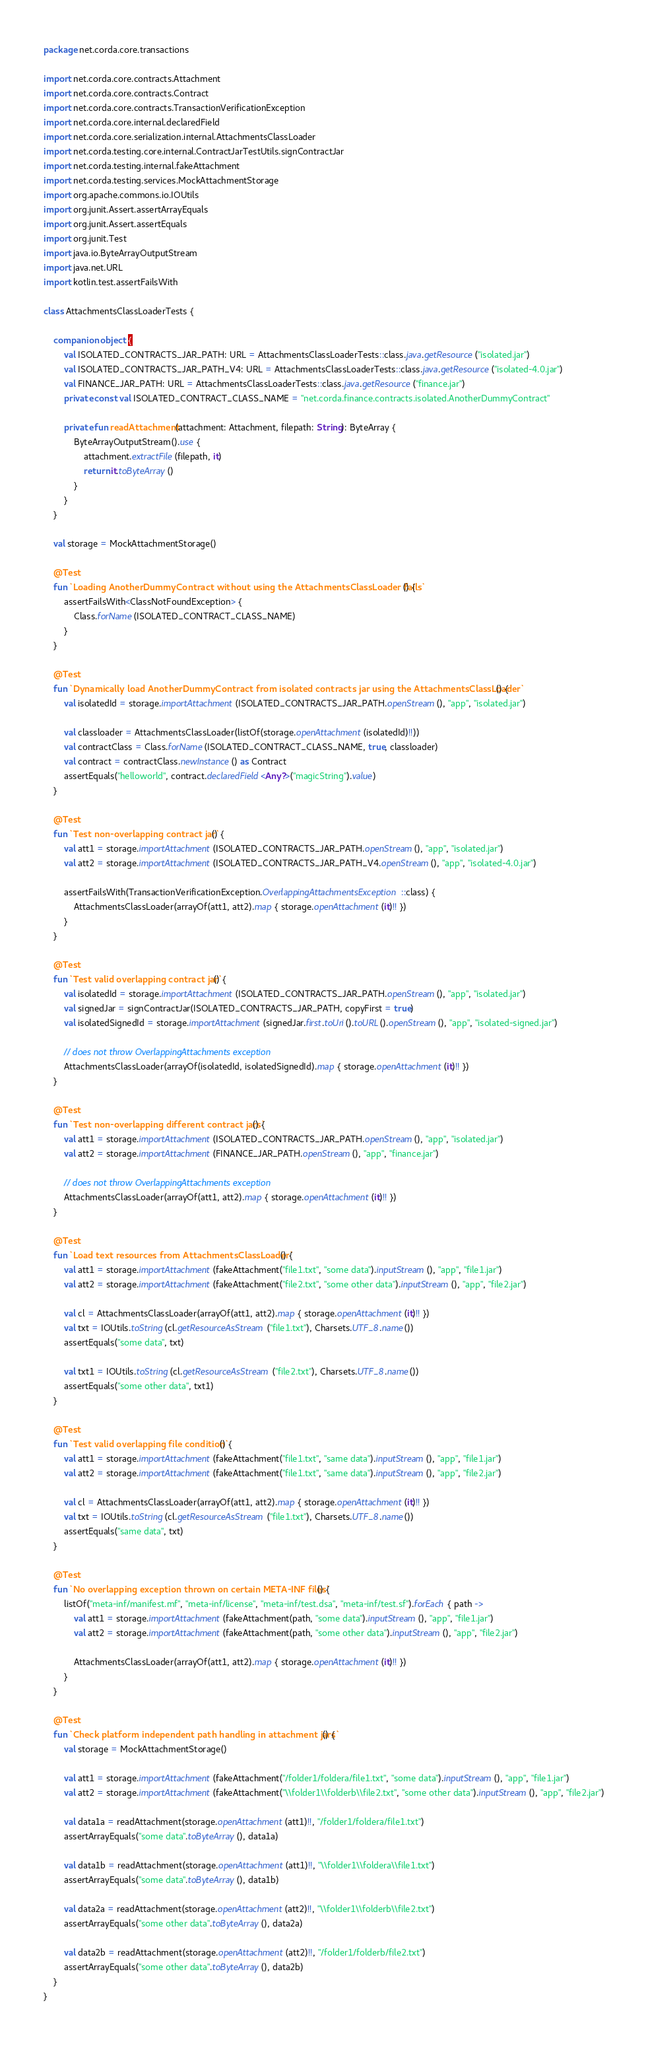<code> <loc_0><loc_0><loc_500><loc_500><_Kotlin_>package net.corda.core.transactions

import net.corda.core.contracts.Attachment
import net.corda.core.contracts.Contract
import net.corda.core.contracts.TransactionVerificationException
import net.corda.core.internal.declaredField
import net.corda.core.serialization.internal.AttachmentsClassLoader
import net.corda.testing.core.internal.ContractJarTestUtils.signContractJar
import net.corda.testing.internal.fakeAttachment
import net.corda.testing.services.MockAttachmentStorage
import org.apache.commons.io.IOUtils
import org.junit.Assert.assertArrayEquals
import org.junit.Assert.assertEquals
import org.junit.Test
import java.io.ByteArrayOutputStream
import java.net.URL
import kotlin.test.assertFailsWith

class AttachmentsClassLoaderTests {

    companion object {
        val ISOLATED_CONTRACTS_JAR_PATH: URL = AttachmentsClassLoaderTests::class.java.getResource("isolated.jar")
        val ISOLATED_CONTRACTS_JAR_PATH_V4: URL = AttachmentsClassLoaderTests::class.java.getResource("isolated-4.0.jar")
        val FINANCE_JAR_PATH: URL = AttachmentsClassLoaderTests::class.java.getResource("finance.jar")
        private const val ISOLATED_CONTRACT_CLASS_NAME = "net.corda.finance.contracts.isolated.AnotherDummyContract"

        private fun readAttachment(attachment: Attachment, filepath: String): ByteArray {
            ByteArrayOutputStream().use {
                attachment.extractFile(filepath, it)
                return it.toByteArray()
            }
        }
    }

    val storage = MockAttachmentStorage()

    @Test
    fun `Loading AnotherDummyContract without using the AttachmentsClassLoader fails`() {
        assertFailsWith<ClassNotFoundException> {
            Class.forName(ISOLATED_CONTRACT_CLASS_NAME)
        }
    }

    @Test
    fun `Dynamically load AnotherDummyContract from isolated contracts jar using the AttachmentsClassLoader`() {
        val isolatedId = storage.importAttachment(ISOLATED_CONTRACTS_JAR_PATH.openStream(), "app", "isolated.jar")

        val classloader = AttachmentsClassLoader(listOf(storage.openAttachment(isolatedId)!!))
        val contractClass = Class.forName(ISOLATED_CONTRACT_CLASS_NAME, true, classloader)
        val contract = contractClass.newInstance() as Contract
        assertEquals("helloworld", contract.declaredField<Any?>("magicString").value)
    }

    @Test
    fun `Test non-overlapping contract jar`() {
        val att1 = storage.importAttachment(ISOLATED_CONTRACTS_JAR_PATH.openStream(), "app", "isolated.jar")
        val att2 = storage.importAttachment(ISOLATED_CONTRACTS_JAR_PATH_V4.openStream(), "app", "isolated-4.0.jar")

        assertFailsWith(TransactionVerificationException.OverlappingAttachmentsException::class) {
            AttachmentsClassLoader(arrayOf(att1, att2).map { storage.openAttachment(it)!! })
        }
    }

    @Test
    fun `Test valid overlapping contract jar`() {
        val isolatedId = storage.importAttachment(ISOLATED_CONTRACTS_JAR_PATH.openStream(), "app", "isolated.jar")
        val signedJar = signContractJar(ISOLATED_CONTRACTS_JAR_PATH, copyFirst = true)
        val isolatedSignedId = storage.importAttachment(signedJar.first.toUri().toURL().openStream(), "app", "isolated-signed.jar")

        // does not throw OverlappingAttachments exception
        AttachmentsClassLoader(arrayOf(isolatedId, isolatedSignedId).map { storage.openAttachment(it)!! })
    }

    @Test
    fun `Test non-overlapping different contract jars`() {
        val att1 = storage.importAttachment(ISOLATED_CONTRACTS_JAR_PATH.openStream(), "app", "isolated.jar")
        val att2 = storage.importAttachment(FINANCE_JAR_PATH.openStream(), "app", "finance.jar")

        // does not throw OverlappingAttachments exception
        AttachmentsClassLoader(arrayOf(att1, att2).map { storage.openAttachment(it)!! })
    }

    @Test
    fun `Load text resources from AttachmentsClassLoader`() {
        val att1 = storage.importAttachment(fakeAttachment("file1.txt", "some data").inputStream(), "app", "file1.jar")
        val att2 = storage.importAttachment(fakeAttachment("file2.txt", "some other data").inputStream(), "app", "file2.jar")

        val cl = AttachmentsClassLoader(arrayOf(att1, att2).map { storage.openAttachment(it)!! })
        val txt = IOUtils.toString(cl.getResourceAsStream("file1.txt"), Charsets.UTF_8.name())
        assertEquals("some data", txt)

        val txt1 = IOUtils.toString(cl.getResourceAsStream("file2.txt"), Charsets.UTF_8.name())
        assertEquals("some other data", txt1)
    }

    @Test
    fun `Test valid overlapping file condition`() {
        val att1 = storage.importAttachment(fakeAttachment("file1.txt", "same data").inputStream(), "app", "file1.jar")
        val att2 = storage.importAttachment(fakeAttachment("file1.txt", "same data").inputStream(), "app", "file2.jar")

        val cl = AttachmentsClassLoader(arrayOf(att1, att2).map { storage.openAttachment(it)!! })
        val txt = IOUtils.toString(cl.getResourceAsStream("file1.txt"), Charsets.UTF_8.name())
        assertEquals("same data", txt)
    }

    @Test
    fun `No overlapping exception thrown on certain META-INF files`() {
        listOf("meta-inf/manifest.mf", "meta-inf/license", "meta-inf/test.dsa", "meta-inf/test.sf").forEach { path ->
            val att1 = storage.importAttachment(fakeAttachment(path, "some data").inputStream(), "app", "file1.jar")
            val att2 = storage.importAttachment(fakeAttachment(path, "some other data").inputStream(), "app", "file2.jar")

            AttachmentsClassLoader(arrayOf(att1, att2).map { storage.openAttachment(it)!! })
        }
    }

    @Test
    fun `Check platform independent path handling in attachment jars`() {
        val storage = MockAttachmentStorage()

        val att1 = storage.importAttachment(fakeAttachment("/folder1/foldera/file1.txt", "some data").inputStream(), "app", "file1.jar")
        val att2 = storage.importAttachment(fakeAttachment("\\folder1\\folderb\\file2.txt", "some other data").inputStream(), "app", "file2.jar")

        val data1a = readAttachment(storage.openAttachment(att1)!!, "/folder1/foldera/file1.txt")
        assertArrayEquals("some data".toByteArray(), data1a)

        val data1b = readAttachment(storage.openAttachment(att1)!!, "\\folder1\\foldera\\file1.txt")
        assertArrayEquals("some data".toByteArray(), data1b)

        val data2a = readAttachment(storage.openAttachment(att2)!!, "\\folder1\\folderb\\file2.txt")
        assertArrayEquals("some other data".toByteArray(), data2a)

        val data2b = readAttachment(storage.openAttachment(att2)!!, "/folder1/folderb/file2.txt")
        assertArrayEquals("some other data".toByteArray(), data2b)
    }
}
</code> 